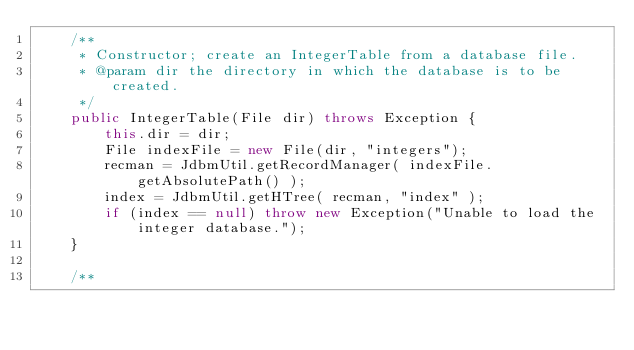<code> <loc_0><loc_0><loc_500><loc_500><_Java_>	/**
	 * Constructor; create an IntegerTable from a database file.
	 * @param dir the directory in which the database is to be created.
	 */
	public IntegerTable(File dir) throws Exception {
		this.dir = dir;
		File indexFile = new File(dir, "integers");
		recman = JdbmUtil.getRecordManager( indexFile.getAbsolutePath() );
		index = JdbmUtil.getHTree( recman, "index" );
		if (index == null) throw new Exception("Unable to load the integer database.");
	}

	/**</code> 